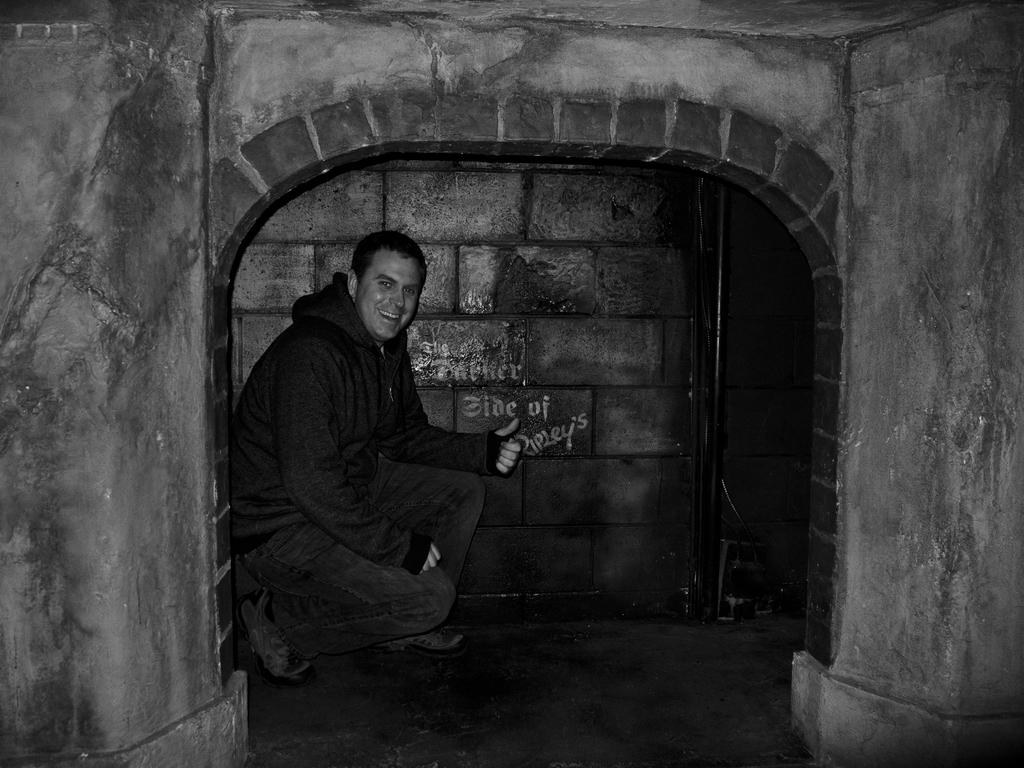What is the color scheme of the image? The image is black and white. What type of room is depicted in the image? There is a den in the image. What are the boundaries of the den made of? The den has walls. Who is present in the den? A man is sitting in the den. What is the man's facial expression? The man has a smiling face. What time is displayed on the clock in the den? There is no clock present in the image; it is a black and white image of a man sitting in a den. 